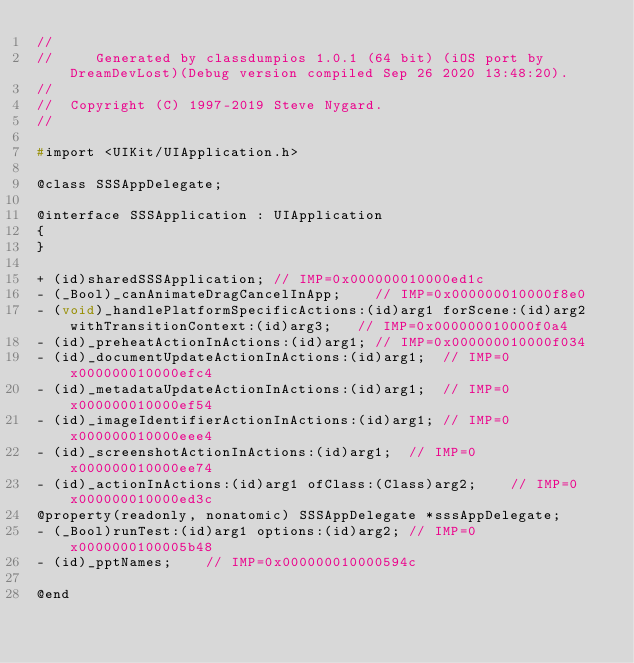<code> <loc_0><loc_0><loc_500><loc_500><_C_>//
//     Generated by classdumpios 1.0.1 (64 bit) (iOS port by DreamDevLost)(Debug version compiled Sep 26 2020 13:48:20).
//
//  Copyright (C) 1997-2019 Steve Nygard.
//

#import <UIKit/UIApplication.h>

@class SSSAppDelegate;

@interface SSSApplication : UIApplication
{
}

+ (id)sharedSSSApplication;	// IMP=0x000000010000ed1c
- (_Bool)_canAnimateDragCancelInApp;	// IMP=0x000000010000f8e0
- (void)_handlePlatformSpecificActions:(id)arg1 forScene:(id)arg2 withTransitionContext:(id)arg3;	// IMP=0x000000010000f0a4
- (id)_preheatActionInActions:(id)arg1;	// IMP=0x000000010000f034
- (id)_documentUpdateActionInActions:(id)arg1;	// IMP=0x000000010000efc4
- (id)_metadataUpdateActionInActions:(id)arg1;	// IMP=0x000000010000ef54
- (id)_imageIdentifierActionInActions:(id)arg1;	// IMP=0x000000010000eee4
- (id)_screenshotActionInActions:(id)arg1;	// IMP=0x000000010000ee74
- (id)_actionInActions:(id)arg1 ofClass:(Class)arg2;	// IMP=0x000000010000ed3c
@property(readonly, nonatomic) SSSAppDelegate *sssAppDelegate;
- (_Bool)runTest:(id)arg1 options:(id)arg2;	// IMP=0x0000000100005b48
- (id)_pptNames;	// IMP=0x000000010000594c

@end

</code> 